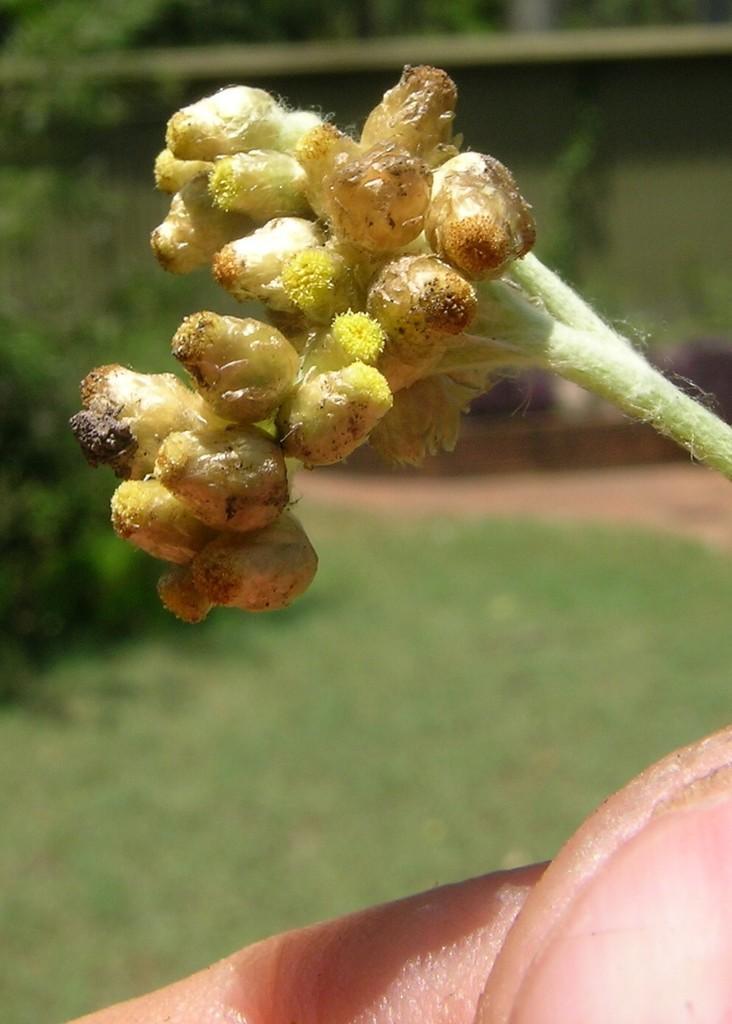Please provide a concise description of this image. As we can see in the image, there is a plant with yellow color bud and the background is blurry. 